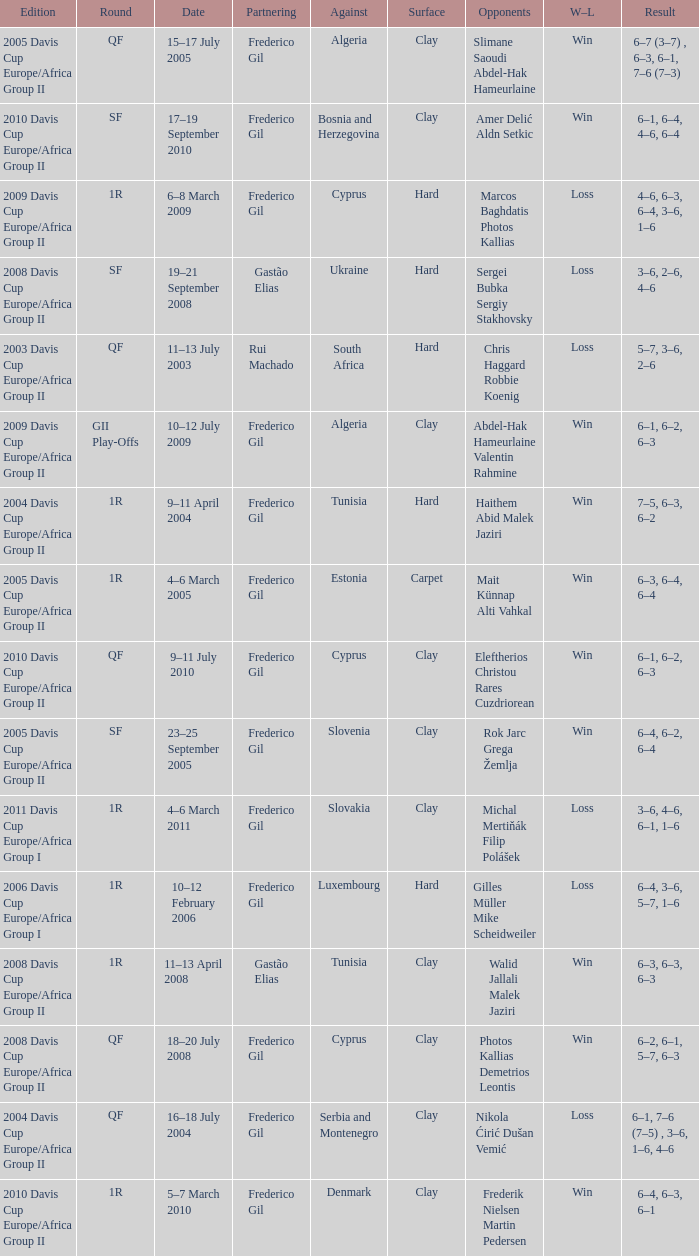How many rounds were there in the 2006 davis cup europe/africa group I? 1.0. 